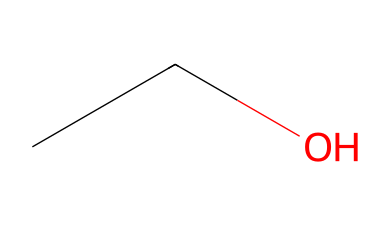What is the molecular formula of this compound? To determine the molecular formula, count the number of carbon (C), hydrogen (H), and oxygen (O) atoms in the structure. The SMILES representation indicates there are two carbon atoms, six hydrogen atoms, and one oxygen atom. Therefore, the molecular formula is C2H6O.
Answer: C2H6O How many carbon atoms are in this compound? The chemical structure has the SMILES representation which shows two carbon atoms present in the chain. This can be directly counted from the notation CC.
Answer: 2 What type of alcohol is represented by this structure? The structure corresponds to ethanol, classified as a primary alcohol due to the hydroxyl (-OH) group attached to a carbon that is bonded to no more than one other carbon.
Answer: primary alcohol What is the total number of hydrogen atoms in this compound? By examining the structure, the SMILES notation indicates that there are six hydrogen atoms associated with the two carbon atoms and one oxygen atom. Thus, the total count is six hydrogen atoms.
Answer: 6 Is this compound saturated or unsaturated? Since all carbons in the structure are single-bonded, and there are no double or triple bonds, the compound is saturated. Saturated compounds have only single bonds connecting carbon atoms.
Answer: saturated What functional group is present in ethanol? The presence of the hydroxyl (-OH) group in the structure indicates that this compound contains an alcohol functional group, which is characteristic of alcohols, including ethanol.
Answer: hydroxyl group How many bonds are between the carbon atoms? In the SMILES representation, the structure shows a connection between two carbon atoms, which are linked by a single bond. Therefore, there is one bond connecting the carbon atoms.
Answer: 1 